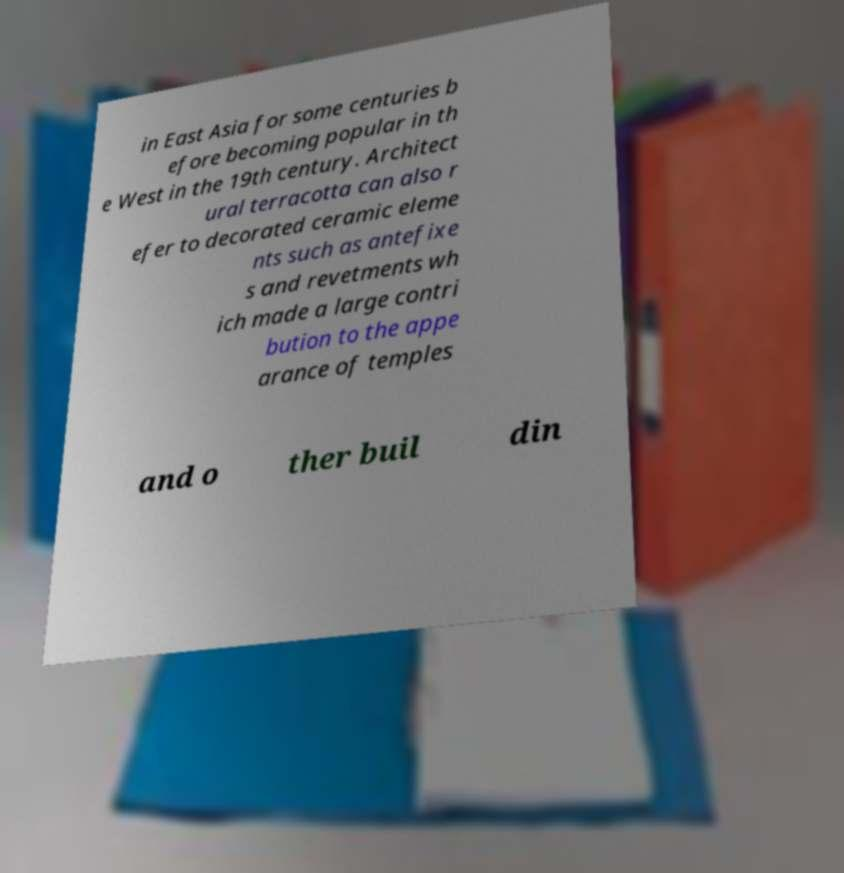There's text embedded in this image that I need extracted. Can you transcribe it verbatim? in East Asia for some centuries b efore becoming popular in th e West in the 19th century. Architect ural terracotta can also r efer to decorated ceramic eleme nts such as antefixe s and revetments wh ich made a large contri bution to the appe arance of temples and o ther buil din 